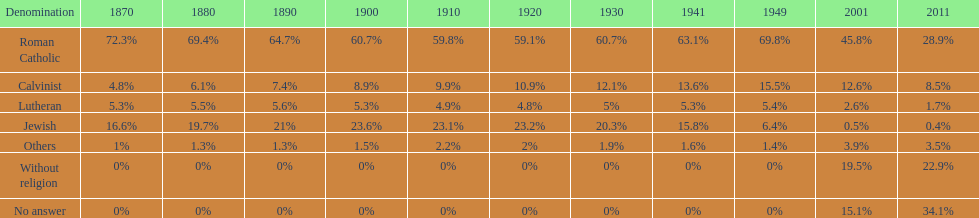Parse the table in full. {'header': ['Denomination', '1870', '1880', '1890', '1900', '1910', '1920', '1930', '1941', '1949', '2001', '2011'], 'rows': [['Roman Catholic', '72.3%', '69.4%', '64.7%', '60.7%', '59.8%', '59.1%', '60.7%', '63.1%', '69.8%', '45.8%', '28.9%'], ['Calvinist', '4.8%', '6.1%', '7.4%', '8.9%', '9.9%', '10.9%', '12.1%', '13.6%', '15.5%', '12.6%', '8.5%'], ['Lutheran', '5.3%', '5.5%', '5.6%', '5.3%', '4.9%', '4.8%', '5%', '5.3%', '5.4%', '2.6%', '1.7%'], ['Jewish', '16.6%', '19.7%', '21%', '23.6%', '23.1%', '23.2%', '20.3%', '15.8%', '6.4%', '0.5%', '0.4%'], ['Others', '1%', '1.3%', '1.3%', '1.5%', '2.2%', '2%', '1.9%', '1.6%', '1.4%', '3.9%', '3.5%'], ['Without religion', '0%', '0%', '0%', '0%', '0%', '0%', '0%', '0%', '0%', '19.5%', '22.9%'], ['No answer', '0%', '0%', '0%', '0%', '0%', '0%', '0%', '0%', '0%', '15.1%', '34.1%']]} How many religious groups never decreased under 20%? 1. 